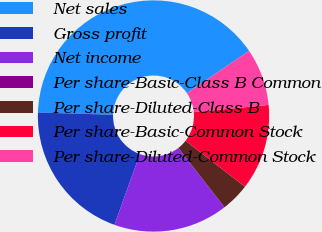Convert chart to OTSL. <chart><loc_0><loc_0><loc_500><loc_500><pie_chart><fcel>Net sales<fcel>Gross profit<fcel>Net income<fcel>Per share-Basic-Class B Common<fcel>Per share-Diluted-Class B<fcel>Per share-Basic-Common Stock<fcel>Per share-Diluted-Common Stock<nl><fcel>40.0%<fcel>20.0%<fcel>16.0%<fcel>0.0%<fcel>4.0%<fcel>12.0%<fcel>8.0%<nl></chart> 